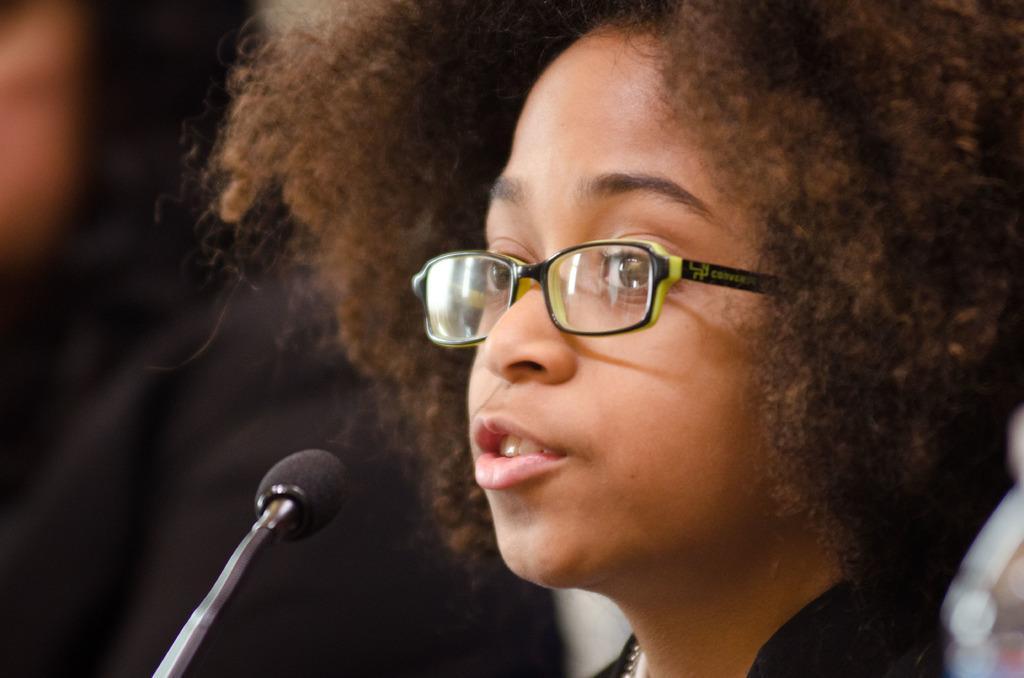How would you summarize this image in a sentence or two? In this image I can see a girl on the right side and I can see she is wearing a specs. On the left side I can see a mic and I can also see this image is little bit blurry in the background. 